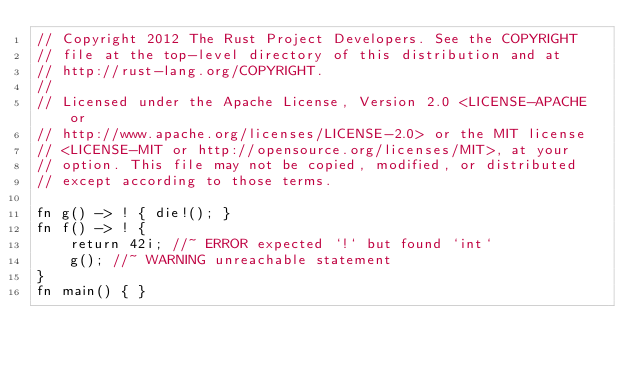Convert code to text. <code><loc_0><loc_0><loc_500><loc_500><_Rust_>// Copyright 2012 The Rust Project Developers. See the COPYRIGHT
// file at the top-level directory of this distribution and at
// http://rust-lang.org/COPYRIGHT.
//
// Licensed under the Apache License, Version 2.0 <LICENSE-APACHE or
// http://www.apache.org/licenses/LICENSE-2.0> or the MIT license
// <LICENSE-MIT or http://opensource.org/licenses/MIT>, at your
// option. This file may not be copied, modified, or distributed
// except according to those terms.

fn g() -> ! { die!(); }
fn f() -> ! {
    return 42i; //~ ERROR expected `!` but found `int`
    g(); //~ WARNING unreachable statement
}
fn main() { }
</code> 